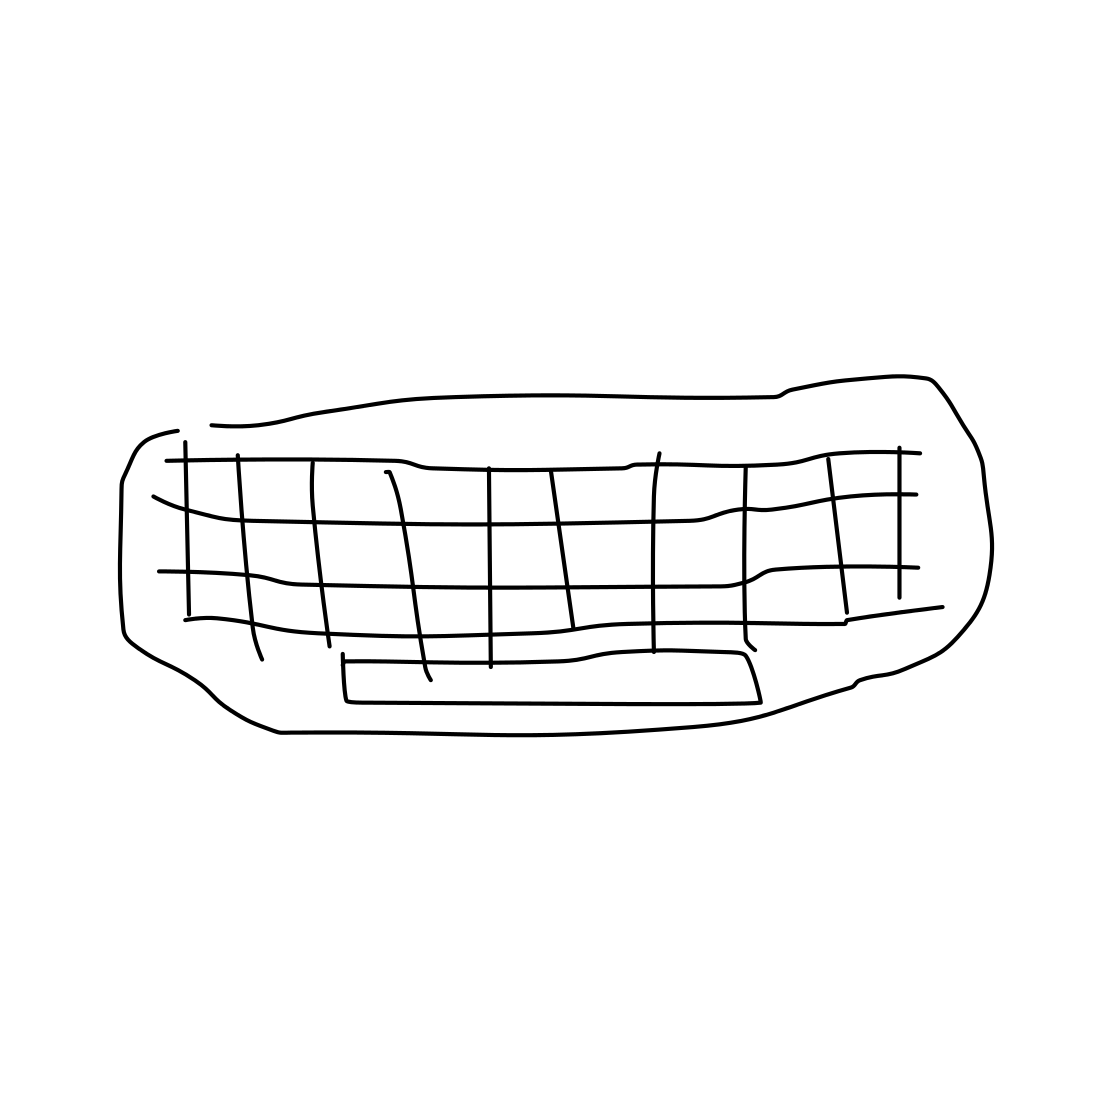Is there a sketchy ear in the picture? The picture doesn't depict an ear or any body parts; it's actually a sketch of what appears to be a couch with a grid pattern on the seating area. 